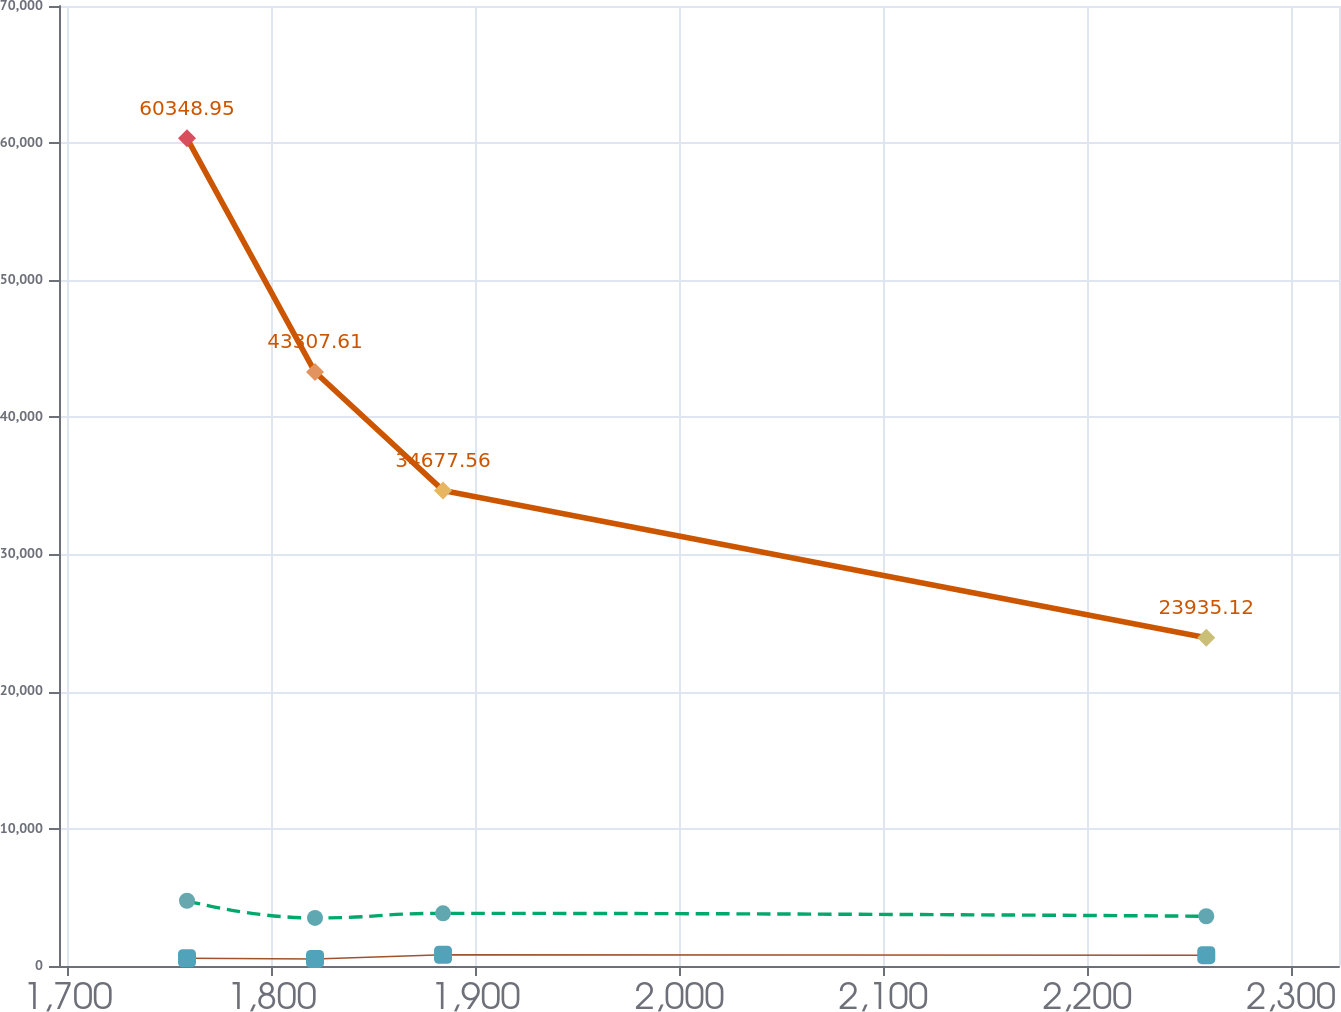<chart> <loc_0><loc_0><loc_500><loc_500><line_chart><ecel><fcel>Depreciation and  Amortization (3)<fcel>Rental and  Related  Revenues (1)<fcel>Operating  Expense (2)<nl><fcel>1758.41<fcel>4755.79<fcel>563.8<fcel>60348.9<nl><fcel>1821.2<fcel>3503.39<fcel>515.15<fcel>43307.6<nl><fcel>1883.99<fcel>3839.09<fcel>822.12<fcel>34677.6<nl><fcel>2258.37<fcel>3628.63<fcel>788.34<fcel>23935.1<nl><fcel>2386.26<fcel>4290.91<fcel>855.9<fcel>19889.1<nl></chart> 